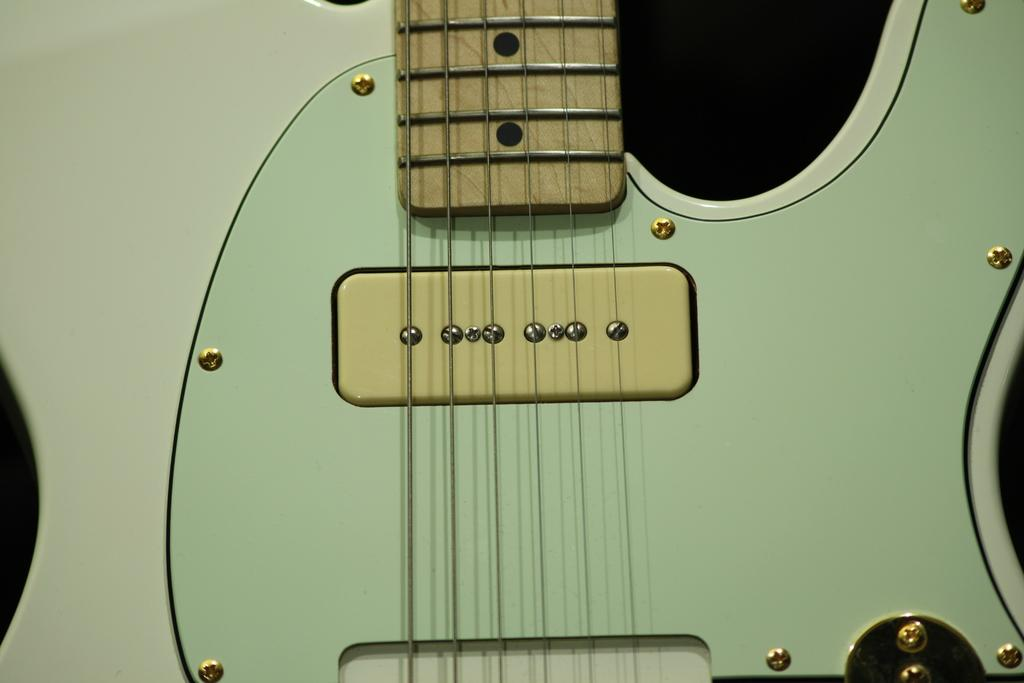What is the main object in the image? There is a guitar in the image. What feature of the guitar is mentioned in the facts? The guitar has strings. How would you describe the background of the image? The background of the image is dark. What type of dirt is visible on the guitar strings in the image? There is no dirt visible on the guitar strings in the image; it only shows a guitar with strings against a dark background. 